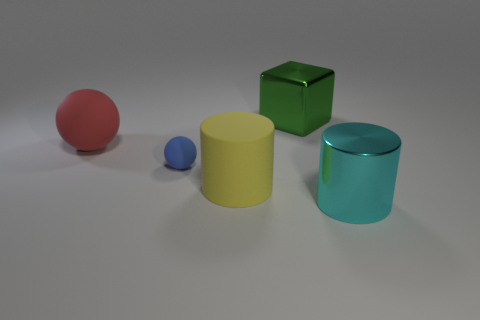What could be a potential use for the green object in the image? The green object in the image is a cube with a reflective surface and looks like a toy block or a decorative piece. In practical terms, if it were a real object, it could serve as a child's plaything, a paperweight, or part of a set for a visual composition in photography or art installations. 